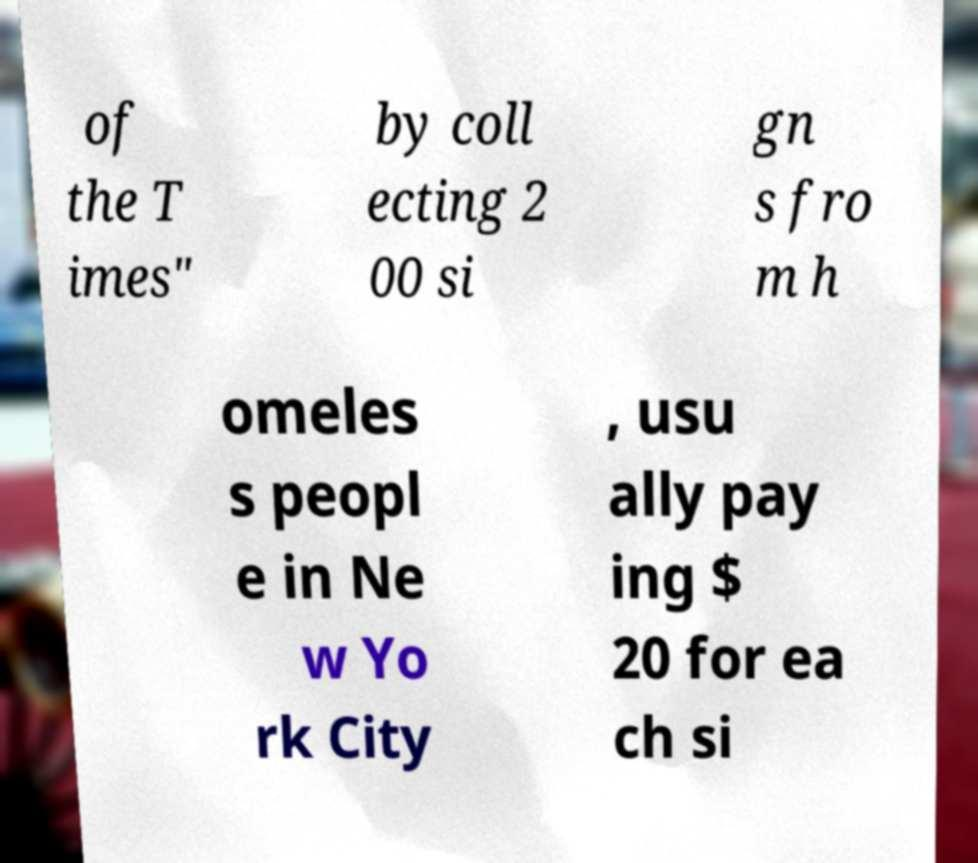For documentation purposes, I need the text within this image transcribed. Could you provide that? of the T imes" by coll ecting 2 00 si gn s fro m h omeles s peopl e in Ne w Yo rk City , usu ally pay ing $ 20 for ea ch si 